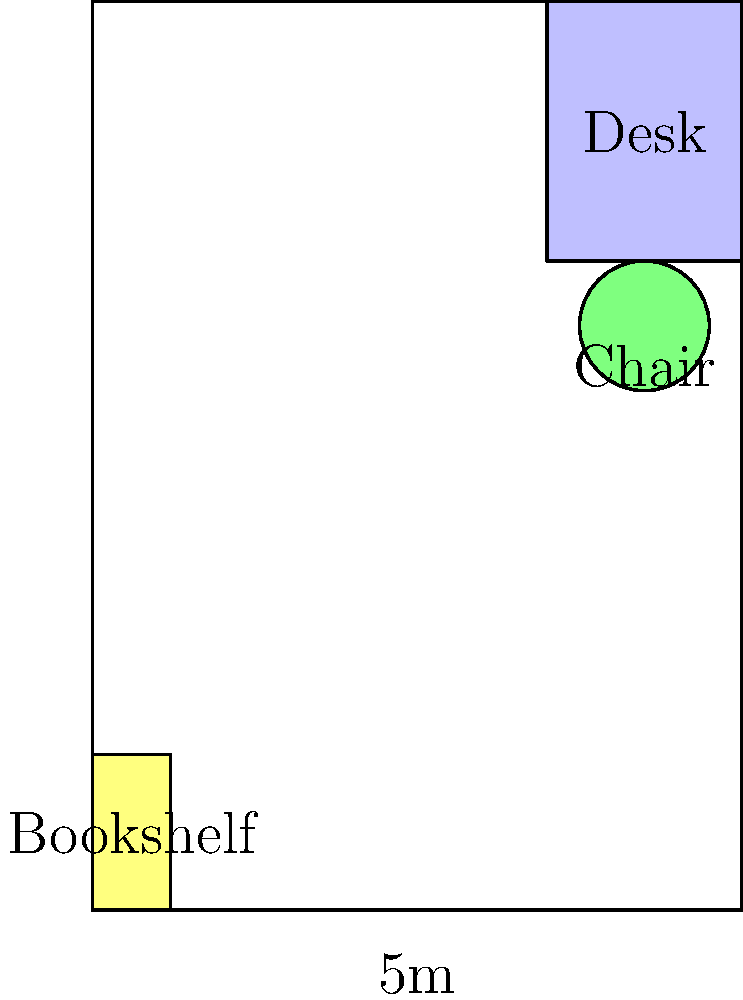Given the floor plan of a home office (5m x 7m) with a desk (1.5m x 2m), chair (radius 0.5m), and bookshelf (0.6m x 1.2m) as shown, calculate the percentage of free floor space available for movement. Round your answer to the nearest whole percent. To calculate the percentage of free floor space, we need to follow these steps:

1. Calculate the total room area:
   $A_{room} = 5m \times 7m = 35m^2$

2. Calculate the area occupied by furniture:
   a. Desk area: $A_{desk} = 1.5m \times 2m = 3m^2$
   b. Chair area (approximated as a square): $A_{chair} = (2 \times 0.5m)^2 = 1m^2$
   c. Bookshelf area: $A_{bookshelf} = 0.6m \times 1.2m = 0.72m^2$
   
   Total furniture area: $A_{furniture} = 3m^2 + 1m^2 + 0.72m^2 = 4.72m^2$

3. Calculate the free floor space:
   $A_{free} = A_{room} - A_{furniture} = 35m^2 - 4.72m^2 = 30.28m^2$

4. Calculate the percentage of free floor space:
   $\text{Percentage} = \frac{A_{free}}{A_{room}} \times 100\% = \frac{30.28m^2}{35m^2} \times 100\% \approx 86.51\%$

5. Round to the nearest whole percent:
   $86.51\% \approx 87\%$
Answer: 87% 